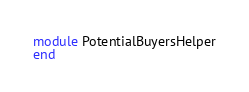<code> <loc_0><loc_0><loc_500><loc_500><_Ruby_>module PotentialBuyersHelper
end
</code> 